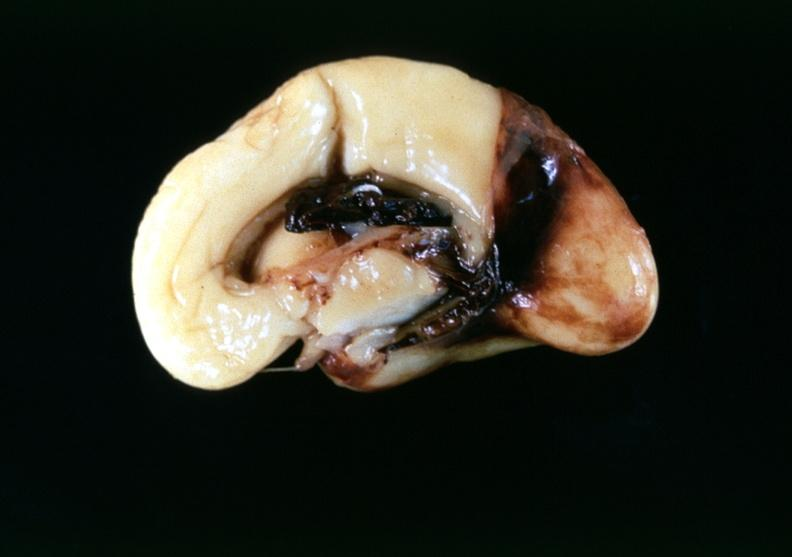s adenocarcinoma present?
Answer the question using a single word or phrase. No 